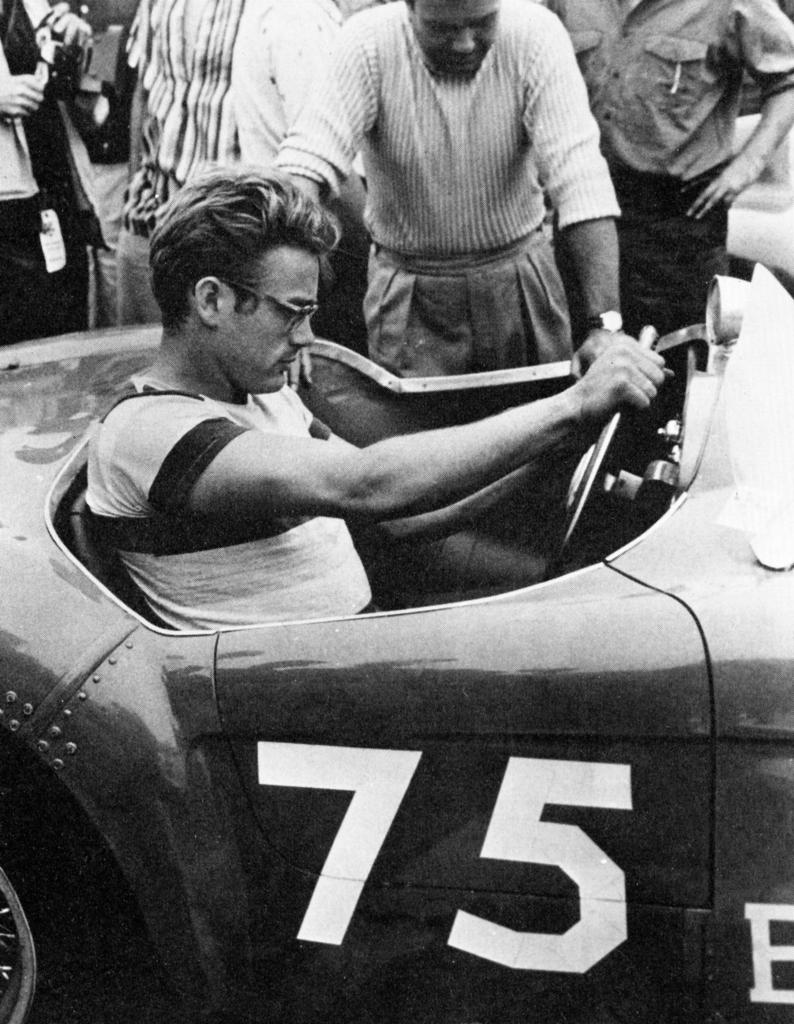What is the main subject in the foreground of the image? There is a person sitting inside a car in the foreground of the image. What can be seen in the background of the image? There are many people in the background of the image. What is the person in the car doing with their hands? The person has their hands on the car. What type of celery is being served on the plate in the image? There is no plate or celery present in the image. 